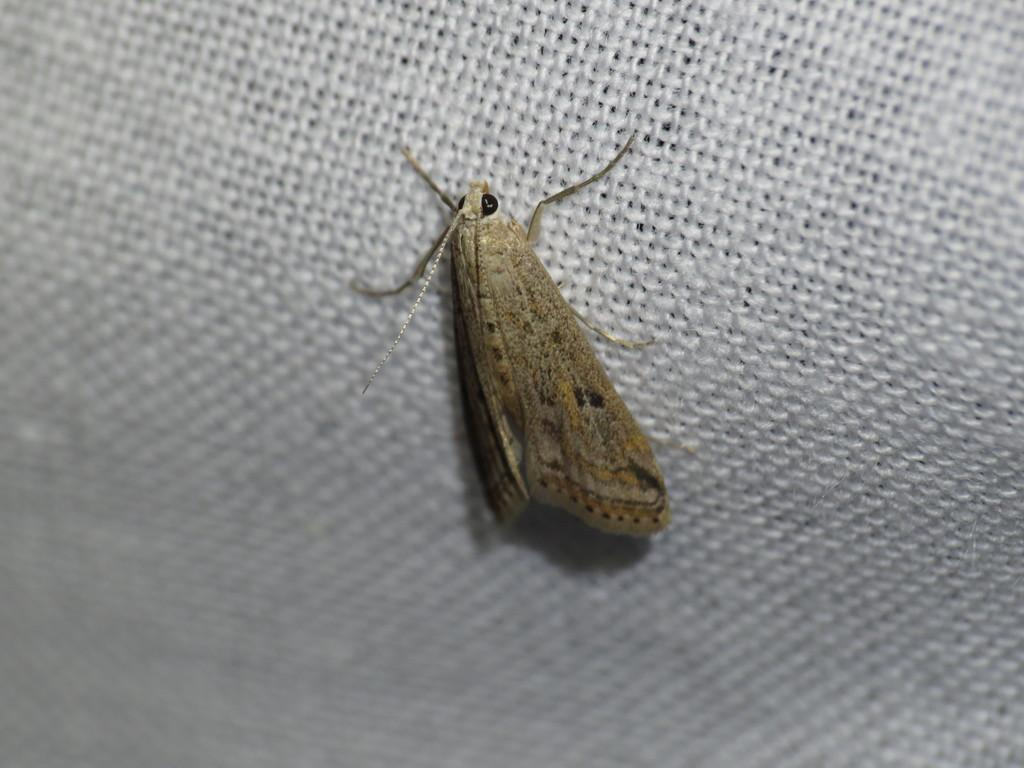What is the main subject of the picture? The main subject of the picture is an insect. What can be observed about the background of the image? The background appears to be white in color. What might the white background be made of? The background might be a net. What type of songs can be heard coming from the insect in the image? There is no indication in the image that the insect is producing any sounds, let alone songs. 